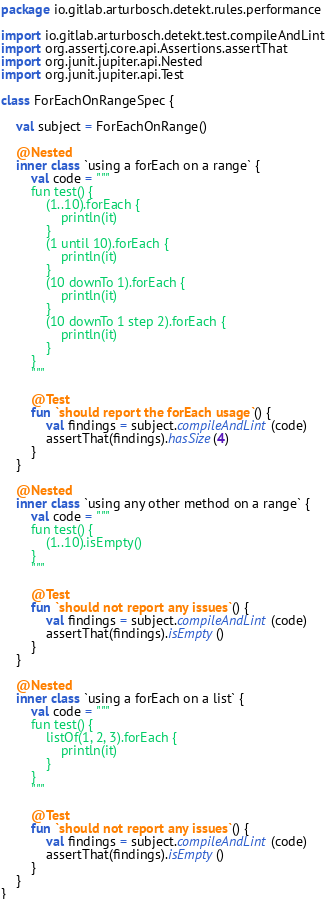<code> <loc_0><loc_0><loc_500><loc_500><_Kotlin_>package io.gitlab.arturbosch.detekt.rules.performance

import io.gitlab.arturbosch.detekt.test.compileAndLint
import org.assertj.core.api.Assertions.assertThat
import org.junit.jupiter.api.Nested
import org.junit.jupiter.api.Test

class ForEachOnRangeSpec {

    val subject = ForEachOnRange()

    @Nested
    inner class `using a forEach on a range` {
        val code = """
        fun test() {
            (1..10).forEach {
                println(it)
            }
            (1 until 10).forEach {
                println(it)
            }
            (10 downTo 1).forEach {
                println(it)
            }
            (10 downTo 1 step 2).forEach {
                println(it)
            }
        }
        """

        @Test
        fun `should report the forEach usage`() {
            val findings = subject.compileAndLint(code)
            assertThat(findings).hasSize(4)
        }
    }

    @Nested
    inner class `using any other method on a range` {
        val code = """
        fun test() {
            (1..10).isEmpty()
        }
        """

        @Test
        fun `should not report any issues`() {
            val findings = subject.compileAndLint(code)
            assertThat(findings).isEmpty()
        }
    }

    @Nested
    inner class `using a forEach on a list` {
        val code = """
        fun test() {
            listOf(1, 2, 3).forEach {
                println(it)
            }
        }
        """

        @Test
        fun `should not report any issues`() {
            val findings = subject.compileAndLint(code)
            assertThat(findings).isEmpty()
        }
    }
}
</code> 